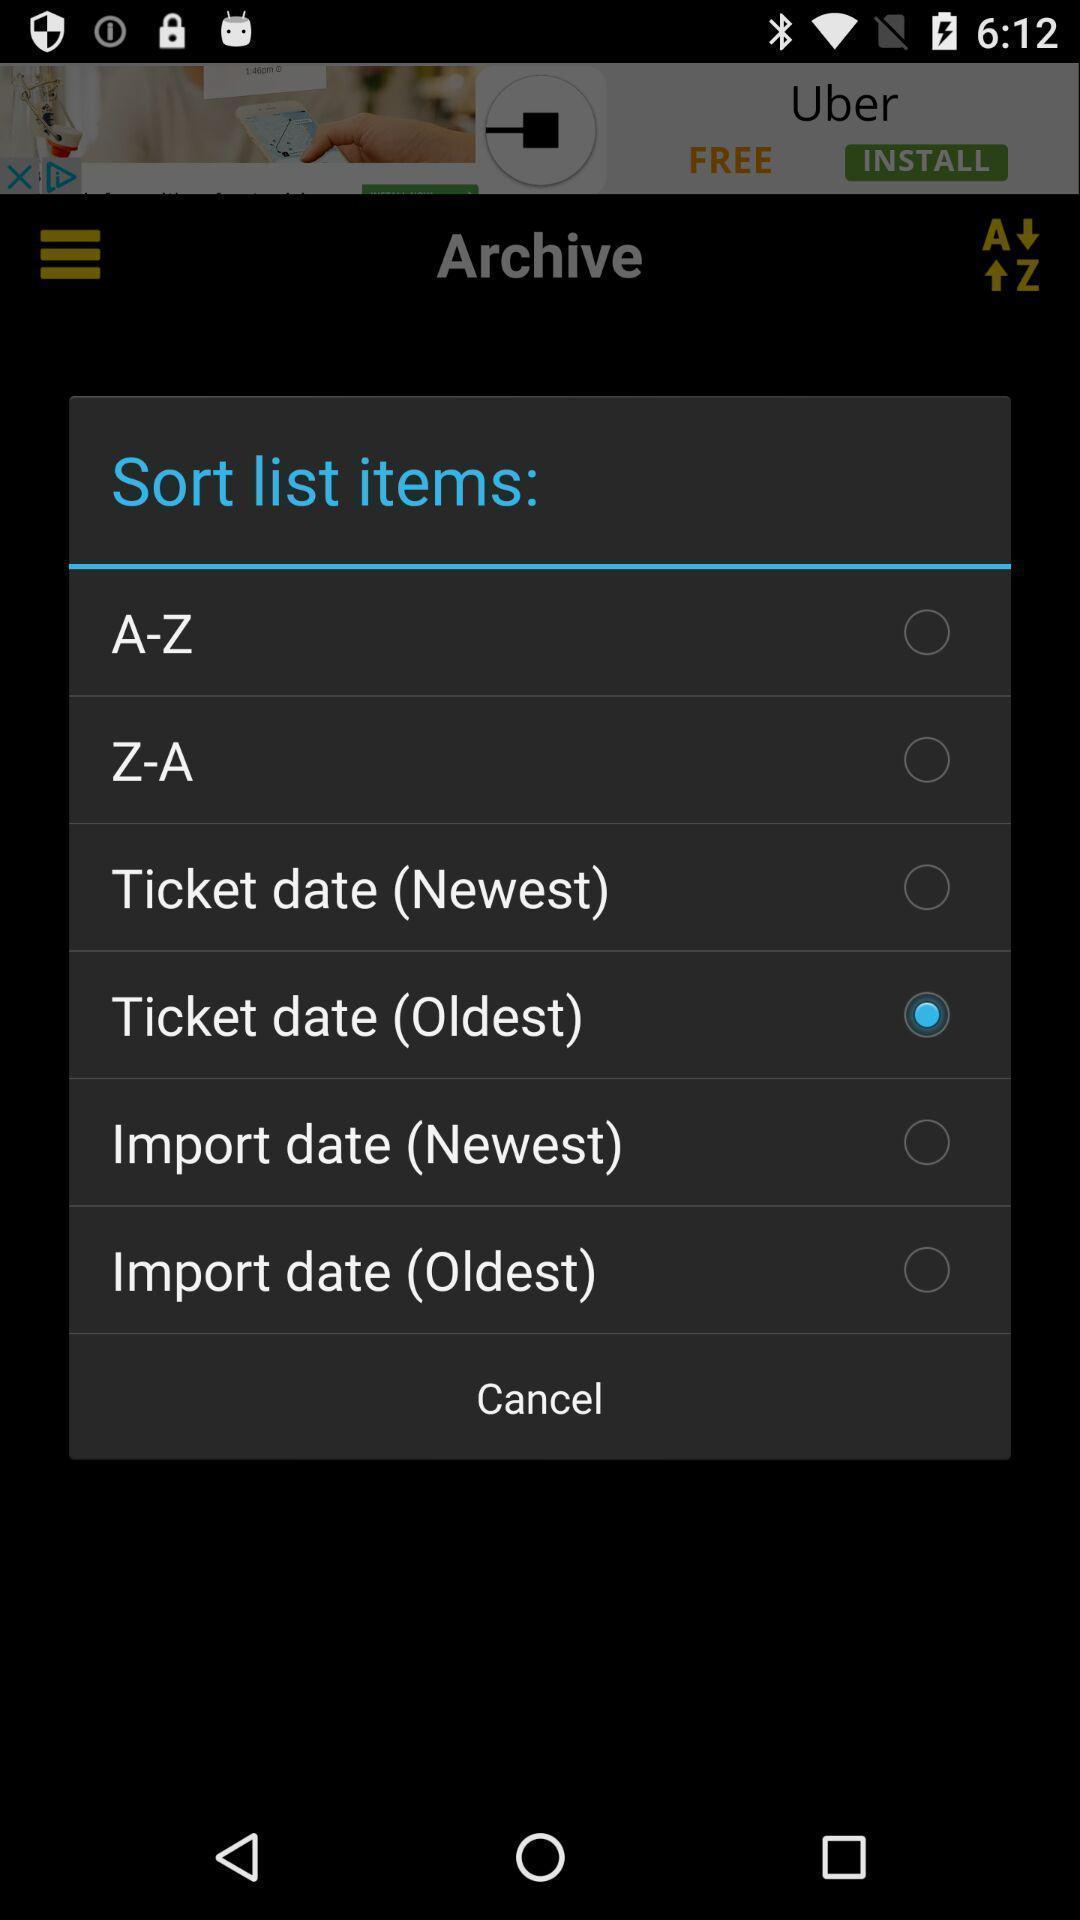What details can you identify in this image? Popup showing few options with cancel option in travel app. 